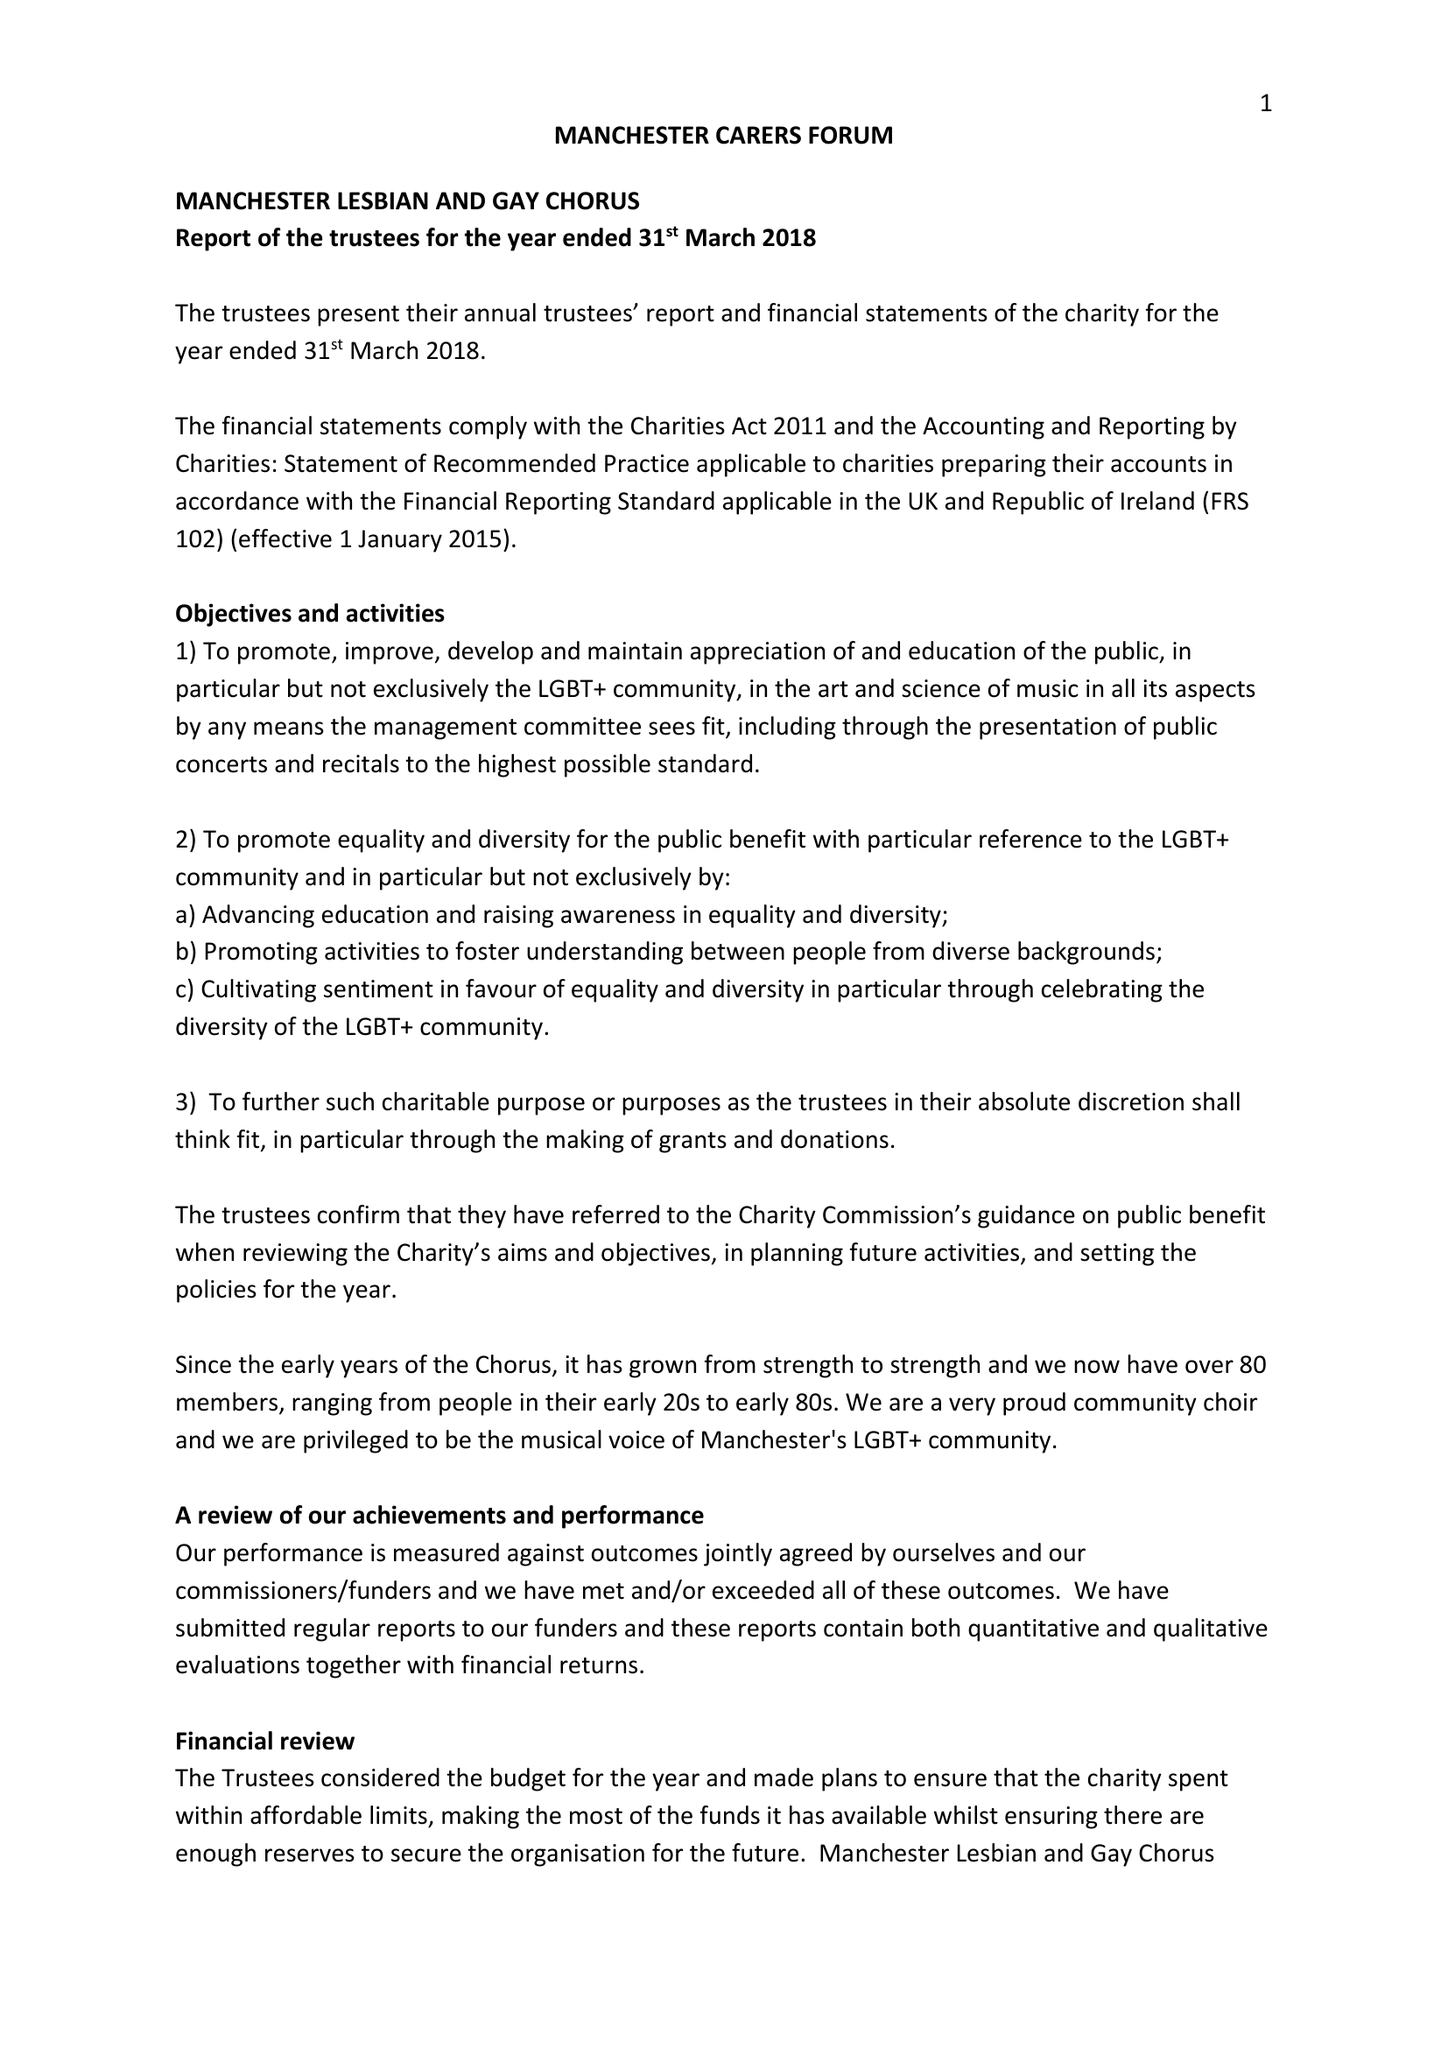What is the value for the address__post_town?
Answer the question using a single word or phrase. CHESTER 